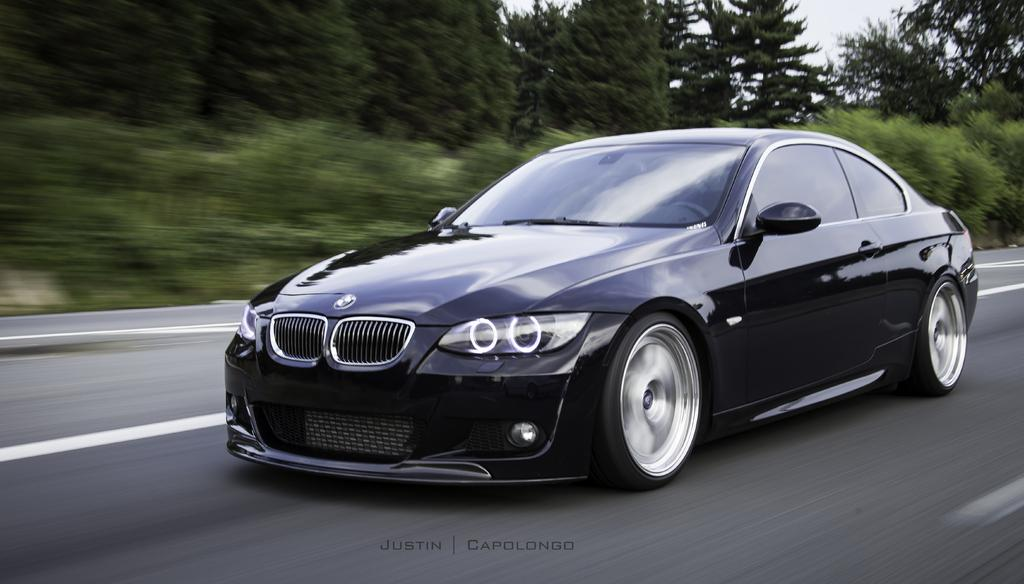What type of car is in the image? There is a black color BMW car in the image. Where is the car located? The car is on the road. What can be seen in the background of the image? There are trees in the background of the image. What type of pest can be seen crawling on the car in the image? There is no pest visible on the car in the image. How many bells are hanging from the trees in the background of the image? There are no bells hanging from the trees in the background of the image. 